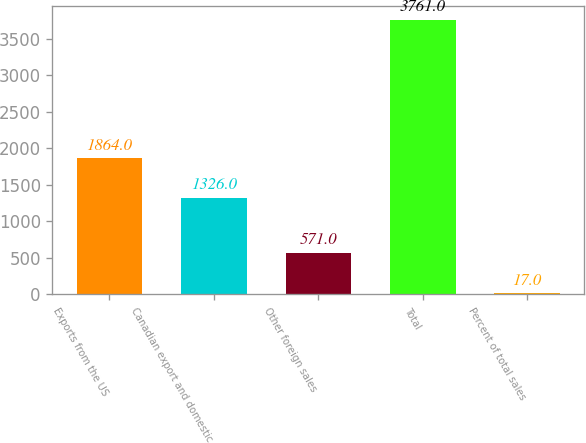<chart> <loc_0><loc_0><loc_500><loc_500><bar_chart><fcel>Exports from the US<fcel>Canadian export and domestic<fcel>Other foreign sales<fcel>Total<fcel>Percent of total sales<nl><fcel>1864<fcel>1326<fcel>571<fcel>3761<fcel>17<nl></chart> 